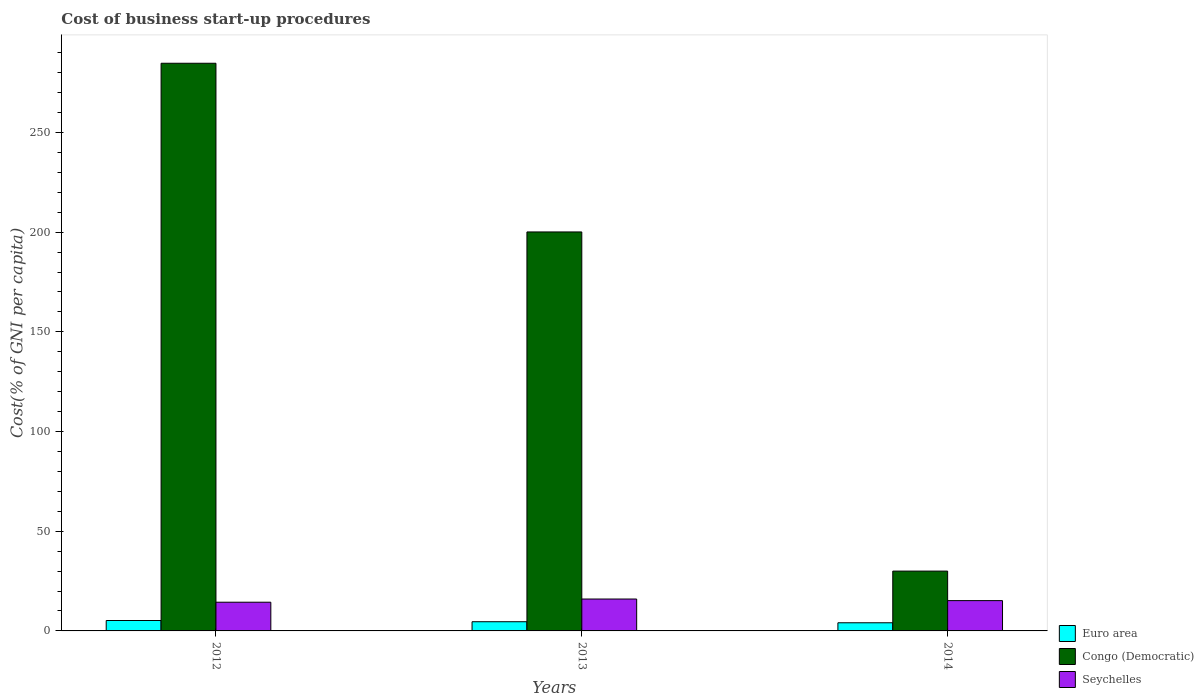How many different coloured bars are there?
Offer a terse response. 3. How many groups of bars are there?
Your answer should be compact. 3. Are the number of bars per tick equal to the number of legend labels?
Ensure brevity in your answer.  Yes. Are the number of bars on each tick of the X-axis equal?
Your answer should be compact. Yes. How many bars are there on the 1st tick from the left?
Make the answer very short. 3. What is the label of the 2nd group of bars from the left?
Your answer should be compact. 2013. What is the cost of business start-up procedures in Seychelles in 2014?
Make the answer very short. 15.2. Across all years, what is the maximum cost of business start-up procedures in Congo (Democratic)?
Your answer should be compact. 284.7. Across all years, what is the minimum cost of business start-up procedures in Euro area?
Your answer should be compact. 4.09. In which year was the cost of business start-up procedures in Seychelles maximum?
Offer a very short reply. 2013. What is the total cost of business start-up procedures in Seychelles in the graph?
Offer a terse response. 45.6. What is the difference between the cost of business start-up procedures in Congo (Democratic) in 2012 and that in 2014?
Provide a succinct answer. 254.7. What is the difference between the cost of business start-up procedures in Congo (Democratic) in 2014 and the cost of business start-up procedures in Euro area in 2013?
Make the answer very short. 25.39. What is the average cost of business start-up procedures in Congo (Democratic) per year?
Keep it short and to the point. 171.6. In the year 2013, what is the difference between the cost of business start-up procedures in Euro area and cost of business start-up procedures in Seychelles?
Your answer should be very brief. -11.39. In how many years, is the cost of business start-up procedures in Seychelles greater than 30 %?
Make the answer very short. 0. What is the ratio of the cost of business start-up procedures in Seychelles in 2012 to that in 2014?
Offer a very short reply. 0.95. What is the difference between the highest and the second highest cost of business start-up procedures in Euro area?
Offer a terse response. 0.62. What is the difference between the highest and the lowest cost of business start-up procedures in Congo (Democratic)?
Offer a very short reply. 254.7. Is the sum of the cost of business start-up procedures in Euro area in 2012 and 2014 greater than the maximum cost of business start-up procedures in Seychelles across all years?
Ensure brevity in your answer.  No. What does the 2nd bar from the left in 2013 represents?
Offer a terse response. Congo (Democratic). What does the 3rd bar from the right in 2012 represents?
Give a very brief answer. Euro area. Is it the case that in every year, the sum of the cost of business start-up procedures in Seychelles and cost of business start-up procedures in Euro area is greater than the cost of business start-up procedures in Congo (Democratic)?
Make the answer very short. No. How many bars are there?
Provide a short and direct response. 9. How many years are there in the graph?
Make the answer very short. 3. What is the difference between two consecutive major ticks on the Y-axis?
Ensure brevity in your answer.  50. Does the graph contain any zero values?
Your answer should be compact. No. Does the graph contain grids?
Offer a terse response. No. Where does the legend appear in the graph?
Ensure brevity in your answer.  Bottom right. How many legend labels are there?
Your answer should be compact. 3. What is the title of the graph?
Ensure brevity in your answer.  Cost of business start-up procedures. Does "Chile" appear as one of the legend labels in the graph?
Give a very brief answer. No. What is the label or title of the X-axis?
Provide a short and direct response. Years. What is the label or title of the Y-axis?
Offer a terse response. Cost(% of GNI per capita). What is the Cost(% of GNI per capita) of Euro area in 2012?
Offer a terse response. 5.23. What is the Cost(% of GNI per capita) of Congo (Democratic) in 2012?
Your response must be concise. 284.7. What is the Cost(% of GNI per capita) in Seychelles in 2012?
Make the answer very short. 14.4. What is the Cost(% of GNI per capita) in Euro area in 2013?
Ensure brevity in your answer.  4.61. What is the Cost(% of GNI per capita) in Congo (Democratic) in 2013?
Ensure brevity in your answer.  200.1. What is the Cost(% of GNI per capita) of Seychelles in 2013?
Provide a short and direct response. 16. What is the Cost(% of GNI per capita) of Euro area in 2014?
Make the answer very short. 4.09. What is the Cost(% of GNI per capita) in Congo (Democratic) in 2014?
Provide a succinct answer. 30. Across all years, what is the maximum Cost(% of GNI per capita) of Euro area?
Your response must be concise. 5.23. Across all years, what is the maximum Cost(% of GNI per capita) in Congo (Democratic)?
Your response must be concise. 284.7. Across all years, what is the minimum Cost(% of GNI per capita) in Euro area?
Make the answer very short. 4.09. Across all years, what is the minimum Cost(% of GNI per capita) of Congo (Democratic)?
Offer a terse response. 30. Across all years, what is the minimum Cost(% of GNI per capita) of Seychelles?
Provide a short and direct response. 14.4. What is the total Cost(% of GNI per capita) of Euro area in the graph?
Offer a very short reply. 13.93. What is the total Cost(% of GNI per capita) of Congo (Democratic) in the graph?
Your response must be concise. 514.8. What is the total Cost(% of GNI per capita) in Seychelles in the graph?
Ensure brevity in your answer.  45.6. What is the difference between the Cost(% of GNI per capita) in Euro area in 2012 and that in 2013?
Your response must be concise. 0.62. What is the difference between the Cost(% of GNI per capita) in Congo (Democratic) in 2012 and that in 2013?
Offer a terse response. 84.6. What is the difference between the Cost(% of GNI per capita) in Euro area in 2012 and that in 2014?
Your answer should be very brief. 1.14. What is the difference between the Cost(% of GNI per capita) of Congo (Democratic) in 2012 and that in 2014?
Offer a terse response. 254.7. What is the difference between the Cost(% of GNI per capita) of Seychelles in 2012 and that in 2014?
Your answer should be compact. -0.8. What is the difference between the Cost(% of GNI per capita) in Euro area in 2013 and that in 2014?
Provide a short and direct response. 0.52. What is the difference between the Cost(% of GNI per capita) of Congo (Democratic) in 2013 and that in 2014?
Your answer should be compact. 170.1. What is the difference between the Cost(% of GNI per capita) in Euro area in 2012 and the Cost(% of GNI per capita) in Congo (Democratic) in 2013?
Give a very brief answer. -194.87. What is the difference between the Cost(% of GNI per capita) in Euro area in 2012 and the Cost(% of GNI per capita) in Seychelles in 2013?
Make the answer very short. -10.77. What is the difference between the Cost(% of GNI per capita) in Congo (Democratic) in 2012 and the Cost(% of GNI per capita) in Seychelles in 2013?
Provide a short and direct response. 268.7. What is the difference between the Cost(% of GNI per capita) of Euro area in 2012 and the Cost(% of GNI per capita) of Congo (Democratic) in 2014?
Provide a short and direct response. -24.77. What is the difference between the Cost(% of GNI per capita) of Euro area in 2012 and the Cost(% of GNI per capita) of Seychelles in 2014?
Your answer should be very brief. -9.97. What is the difference between the Cost(% of GNI per capita) in Congo (Democratic) in 2012 and the Cost(% of GNI per capita) in Seychelles in 2014?
Ensure brevity in your answer.  269.5. What is the difference between the Cost(% of GNI per capita) of Euro area in 2013 and the Cost(% of GNI per capita) of Congo (Democratic) in 2014?
Make the answer very short. -25.39. What is the difference between the Cost(% of GNI per capita) in Euro area in 2013 and the Cost(% of GNI per capita) in Seychelles in 2014?
Make the answer very short. -10.59. What is the difference between the Cost(% of GNI per capita) in Congo (Democratic) in 2013 and the Cost(% of GNI per capita) in Seychelles in 2014?
Your response must be concise. 184.9. What is the average Cost(% of GNI per capita) in Euro area per year?
Your answer should be compact. 4.64. What is the average Cost(% of GNI per capita) in Congo (Democratic) per year?
Your answer should be very brief. 171.6. In the year 2012, what is the difference between the Cost(% of GNI per capita) of Euro area and Cost(% of GNI per capita) of Congo (Democratic)?
Your answer should be very brief. -279.47. In the year 2012, what is the difference between the Cost(% of GNI per capita) in Euro area and Cost(% of GNI per capita) in Seychelles?
Provide a short and direct response. -9.17. In the year 2012, what is the difference between the Cost(% of GNI per capita) in Congo (Democratic) and Cost(% of GNI per capita) in Seychelles?
Your answer should be very brief. 270.3. In the year 2013, what is the difference between the Cost(% of GNI per capita) of Euro area and Cost(% of GNI per capita) of Congo (Democratic)?
Your response must be concise. -195.49. In the year 2013, what is the difference between the Cost(% of GNI per capita) of Euro area and Cost(% of GNI per capita) of Seychelles?
Make the answer very short. -11.39. In the year 2013, what is the difference between the Cost(% of GNI per capita) of Congo (Democratic) and Cost(% of GNI per capita) of Seychelles?
Provide a succinct answer. 184.1. In the year 2014, what is the difference between the Cost(% of GNI per capita) in Euro area and Cost(% of GNI per capita) in Congo (Democratic)?
Provide a succinct answer. -25.91. In the year 2014, what is the difference between the Cost(% of GNI per capita) in Euro area and Cost(% of GNI per capita) in Seychelles?
Your response must be concise. -11.11. In the year 2014, what is the difference between the Cost(% of GNI per capita) in Congo (Democratic) and Cost(% of GNI per capita) in Seychelles?
Provide a short and direct response. 14.8. What is the ratio of the Cost(% of GNI per capita) of Euro area in 2012 to that in 2013?
Give a very brief answer. 1.13. What is the ratio of the Cost(% of GNI per capita) of Congo (Democratic) in 2012 to that in 2013?
Give a very brief answer. 1.42. What is the ratio of the Cost(% of GNI per capita) in Seychelles in 2012 to that in 2013?
Your response must be concise. 0.9. What is the ratio of the Cost(% of GNI per capita) in Euro area in 2012 to that in 2014?
Your response must be concise. 1.28. What is the ratio of the Cost(% of GNI per capita) of Congo (Democratic) in 2012 to that in 2014?
Provide a short and direct response. 9.49. What is the ratio of the Cost(% of GNI per capita) of Seychelles in 2012 to that in 2014?
Give a very brief answer. 0.95. What is the ratio of the Cost(% of GNI per capita) in Euro area in 2013 to that in 2014?
Make the answer very short. 1.13. What is the ratio of the Cost(% of GNI per capita) in Congo (Democratic) in 2013 to that in 2014?
Keep it short and to the point. 6.67. What is the ratio of the Cost(% of GNI per capita) of Seychelles in 2013 to that in 2014?
Offer a very short reply. 1.05. What is the difference between the highest and the second highest Cost(% of GNI per capita) of Euro area?
Your answer should be compact. 0.62. What is the difference between the highest and the second highest Cost(% of GNI per capita) of Congo (Democratic)?
Provide a short and direct response. 84.6. What is the difference between the highest and the lowest Cost(% of GNI per capita) of Euro area?
Ensure brevity in your answer.  1.14. What is the difference between the highest and the lowest Cost(% of GNI per capita) of Congo (Democratic)?
Provide a succinct answer. 254.7. 